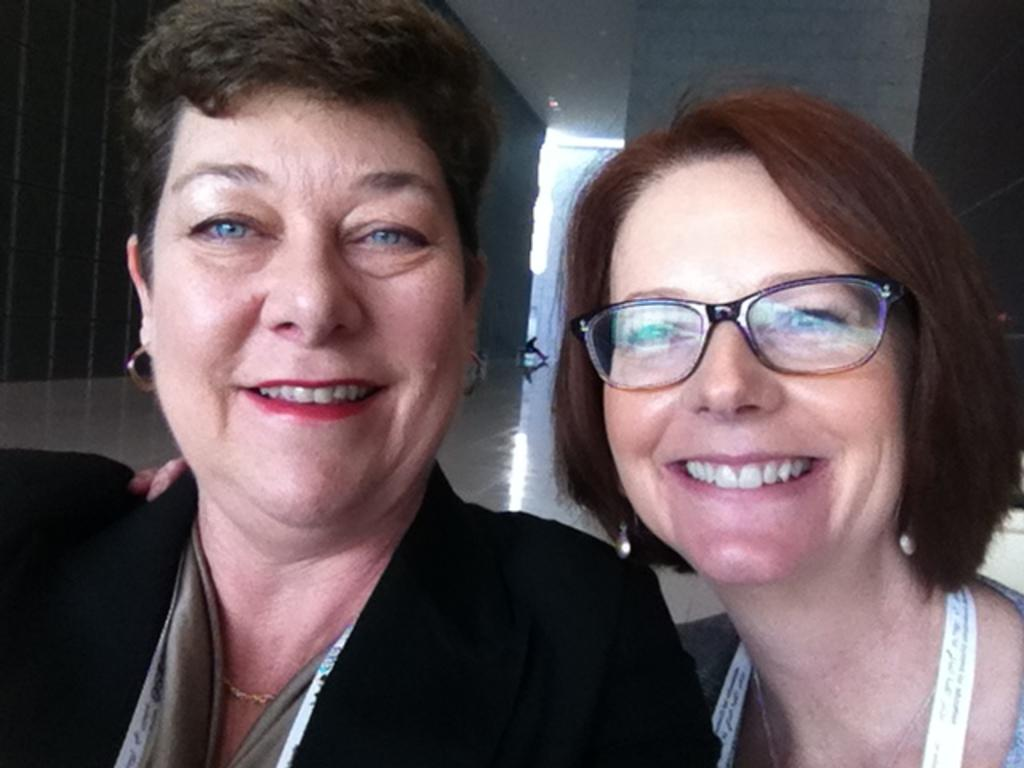How many women are visible in the front of the image? There are two women smiling in the front of the image. What is a distinctive feature of one of the women in the front? One of the women in the front is wearing spectacles. Where is the third woman located in the image? There is a woman on the right side of the image. What can be seen in the background of the image? There is a wall in the background of the image. What type of wood is being used to build the love seat in the image? There is no love seat present in the image, and therefore no wood can be observed. How does the receipt affect the interaction between the women in the image? There is no mention of a receipt in the image, so its impact on the interaction between the women cannot be determined. 